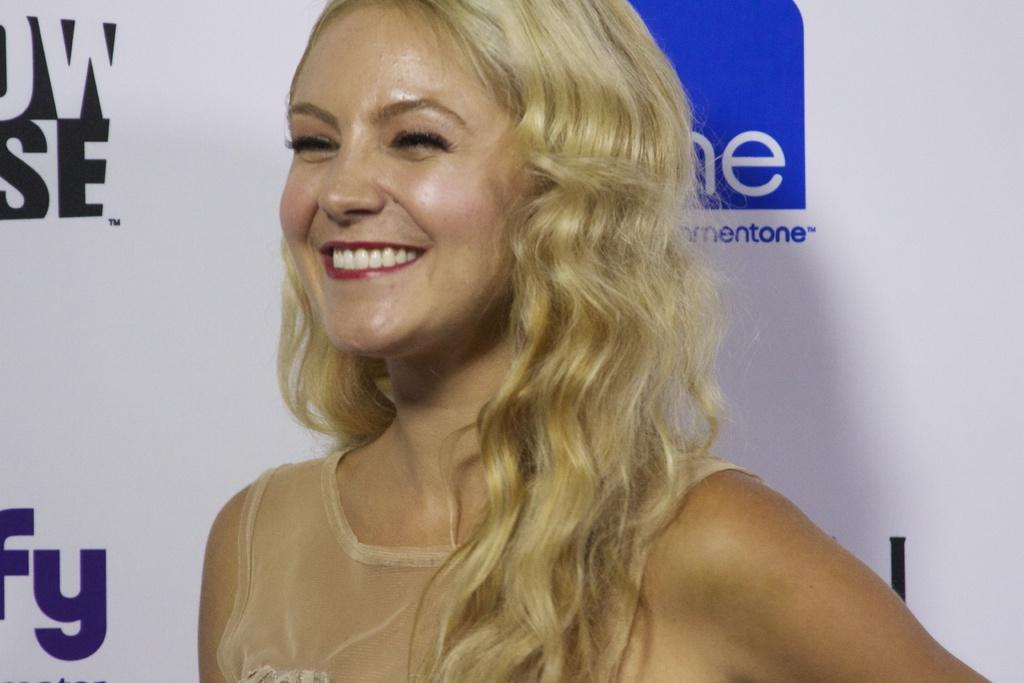Who is present in the image? There is a woman in the image. What is the woman doing in the image? The woman is standing in the image. What is the woman's facial expression in the image? The woman is smiling in the image. What else can be seen in the image besides the woman? There is a banner in the image. What is written on the banner? The banner has something written on it. What type of coil is being used to fulfill the woman's desires in the image? There is no coil or reference to desires in the image; it simply shows a woman standing and smiling with a banner. 